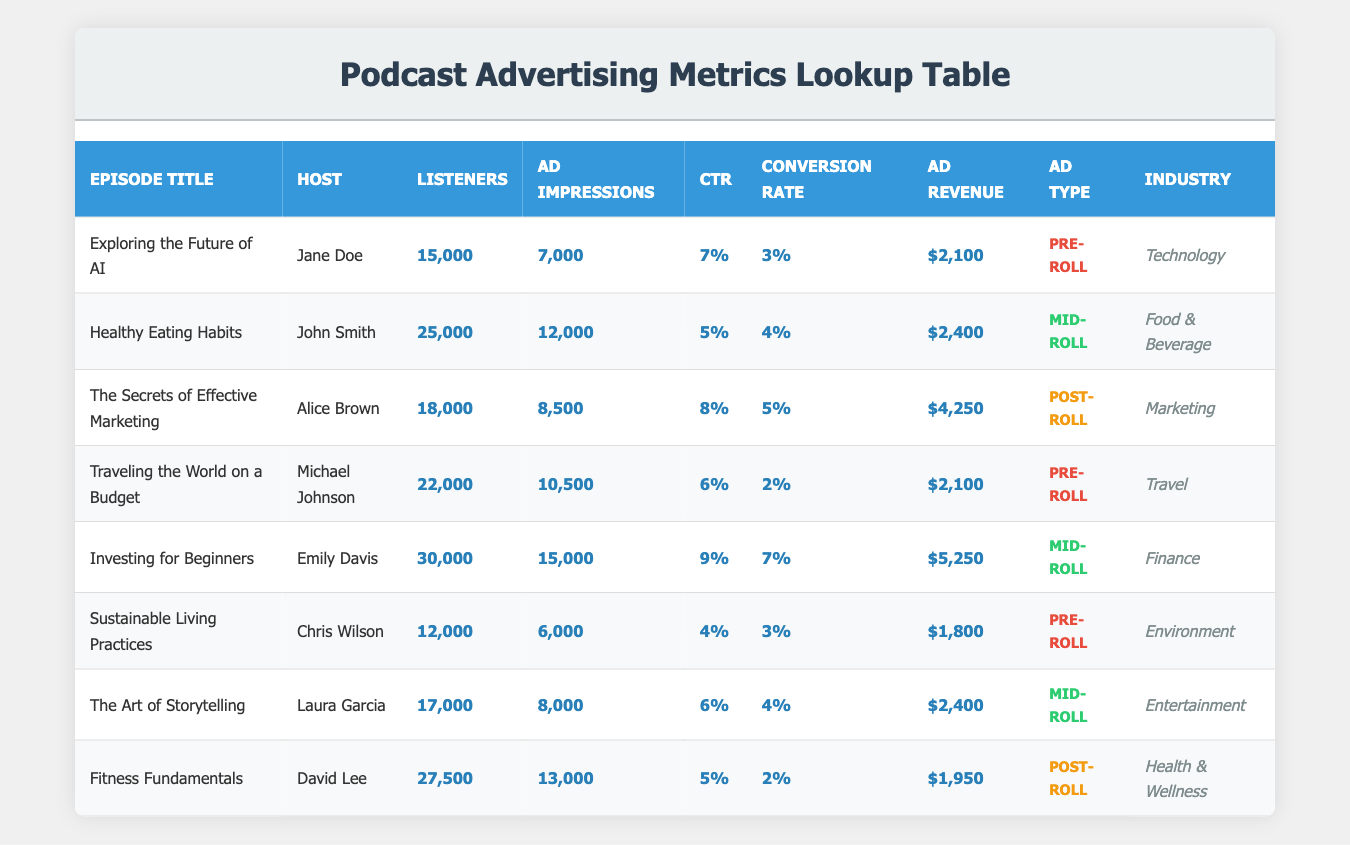What is the ad revenue for the episode "Investing for Beginners"? The ad revenue for "Investing for Beginners" is directly listed in the table under the "Ad Revenue" column next to the respective episode. It shows $5,250.
Answer: $5,250 Which episode has the highest listener count? By comparing the "Listeners" column for all episodes, "Investing for Beginners" has the highest value at 30,000.
Answer: "Investing for Beginners" What is the click-through rate for the episode "The Art of Storytelling"? The click-through rate (CTR) for "The Art of Storytelling" is listed in the "CTR" column of the table as 6%.
Answer: 6% How many total ad impressions were made across all episodes? Adding the ad impressions from each episode: 7000 + 12000 + 8500 + 10500 + 15000 + 6000 + 8000 + 13000 = 75000.
Answer: 75000 Is the conversion rate for the episode "Healthy Eating Habits" above 3%? The conversion rate for "Healthy Eating Habits" is 4%, which is indeed above 3%.
Answer: Yes What is the average ad revenue for episodes with the "Mid-roll" ad type? The ad revenue for "Mid-roll" episodes are: $2,400 (Healthy Eating Habits) and $5,250 (Investing for Beginners). The average is (2400 + 5250) / 2 = $3,825.
Answer: $3,825 Which episode type generally has the highest conversion rate based on the given data? Looking at the conversion rates for each ad type, the mid-roll episodes ("Healthy Eating Habits" and "Investing for Beginners") have the highest average conversion rate of (4% + 7%) / 2 = 5.5%.
Answer: Mid-roll How many episodes belong to the "Food & Beverage" industry, and what are their titles? There is 1 episode in the "Food & Beverage" industry, which is titled "Healthy Eating Habits."
Answer: 1 episode, "Healthy Eating Habits" What is the difference in listener count between "Fitness Fundamentals" and "Sustainable Living Practices"? "Fitness Fundamentals" has 27,500 listeners and "Sustainable Living Practices" has 12,000 listeners. The difference is 27,500 - 12,000 = 15,500.
Answer: 15,500 